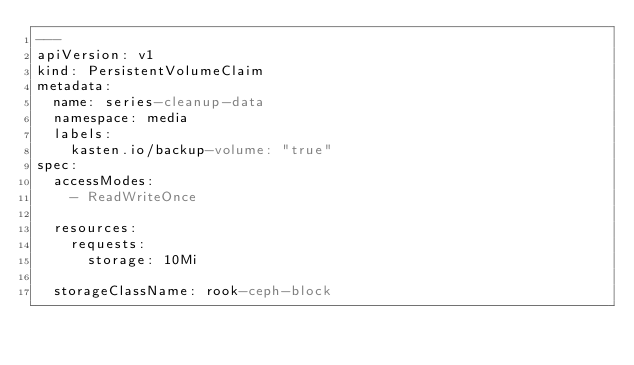Convert code to text. <code><loc_0><loc_0><loc_500><loc_500><_YAML_>---
apiVersion: v1
kind: PersistentVolumeClaim
metadata:
  name: series-cleanup-data
  namespace: media
  labels:
    kasten.io/backup-volume: "true"
spec:
  accessModes:
    - ReadWriteOnce

  resources:
    requests:
      storage: 10Mi

  storageClassName: rook-ceph-block
</code> 